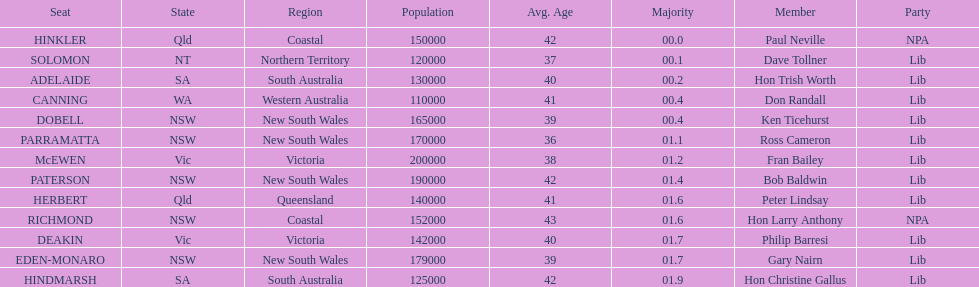What was the complete majority figure for the dobell seat? 00.4. 